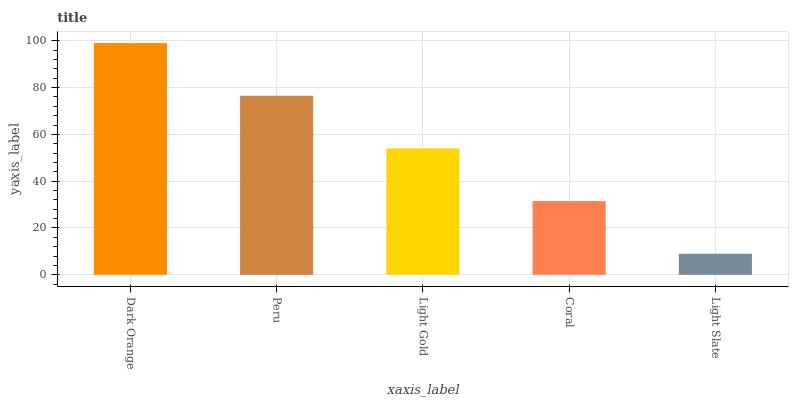Is Light Slate the minimum?
Answer yes or no. Yes. Is Dark Orange the maximum?
Answer yes or no. Yes. Is Peru the minimum?
Answer yes or no. No. Is Peru the maximum?
Answer yes or no. No. Is Dark Orange greater than Peru?
Answer yes or no. Yes. Is Peru less than Dark Orange?
Answer yes or no. Yes. Is Peru greater than Dark Orange?
Answer yes or no. No. Is Dark Orange less than Peru?
Answer yes or no. No. Is Light Gold the high median?
Answer yes or no. Yes. Is Light Gold the low median?
Answer yes or no. Yes. Is Peru the high median?
Answer yes or no. No. Is Peru the low median?
Answer yes or no. No. 